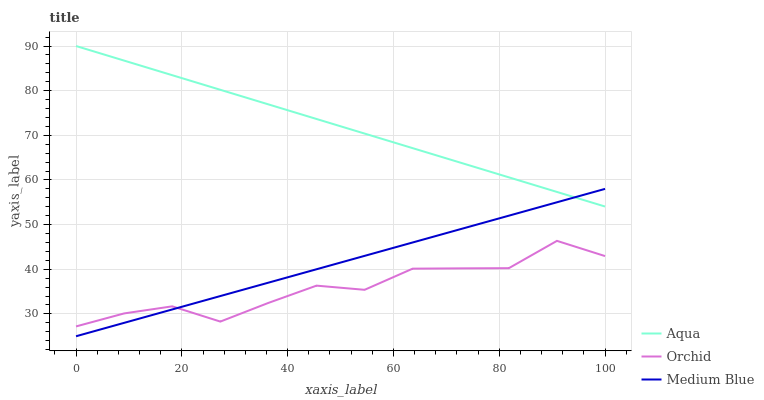Does Orchid have the minimum area under the curve?
Answer yes or no. Yes. Does Aqua have the maximum area under the curve?
Answer yes or no. Yes. Does Aqua have the minimum area under the curve?
Answer yes or no. No. Does Orchid have the maximum area under the curve?
Answer yes or no. No. Is Medium Blue the smoothest?
Answer yes or no. Yes. Is Orchid the roughest?
Answer yes or no. Yes. Is Aqua the smoothest?
Answer yes or no. No. Is Aqua the roughest?
Answer yes or no. No. Does Medium Blue have the lowest value?
Answer yes or no. Yes. Does Orchid have the lowest value?
Answer yes or no. No. Does Aqua have the highest value?
Answer yes or no. Yes. Does Orchid have the highest value?
Answer yes or no. No. Is Orchid less than Aqua?
Answer yes or no. Yes. Is Aqua greater than Orchid?
Answer yes or no. Yes. Does Aqua intersect Medium Blue?
Answer yes or no. Yes. Is Aqua less than Medium Blue?
Answer yes or no. No. Is Aqua greater than Medium Blue?
Answer yes or no. No. Does Orchid intersect Aqua?
Answer yes or no. No. 